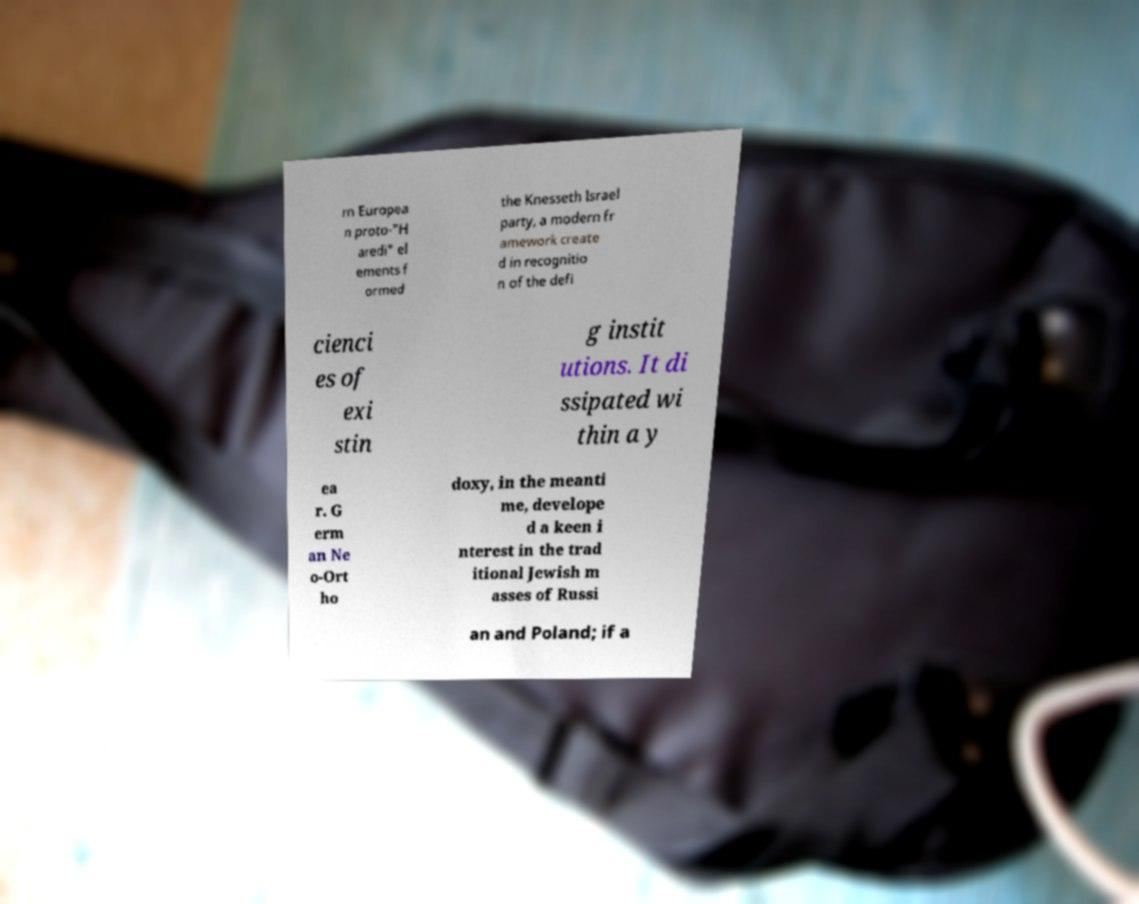Could you assist in decoding the text presented in this image and type it out clearly? rn Europea n proto-"H aredi" el ements f ormed the Knesseth Israel party, a modern fr amework create d in recognitio n of the defi cienci es of exi stin g instit utions. It di ssipated wi thin a y ea r. G erm an Ne o-Ort ho doxy, in the meanti me, develope d a keen i nterest in the trad itional Jewish m asses of Russi an and Poland; if a 